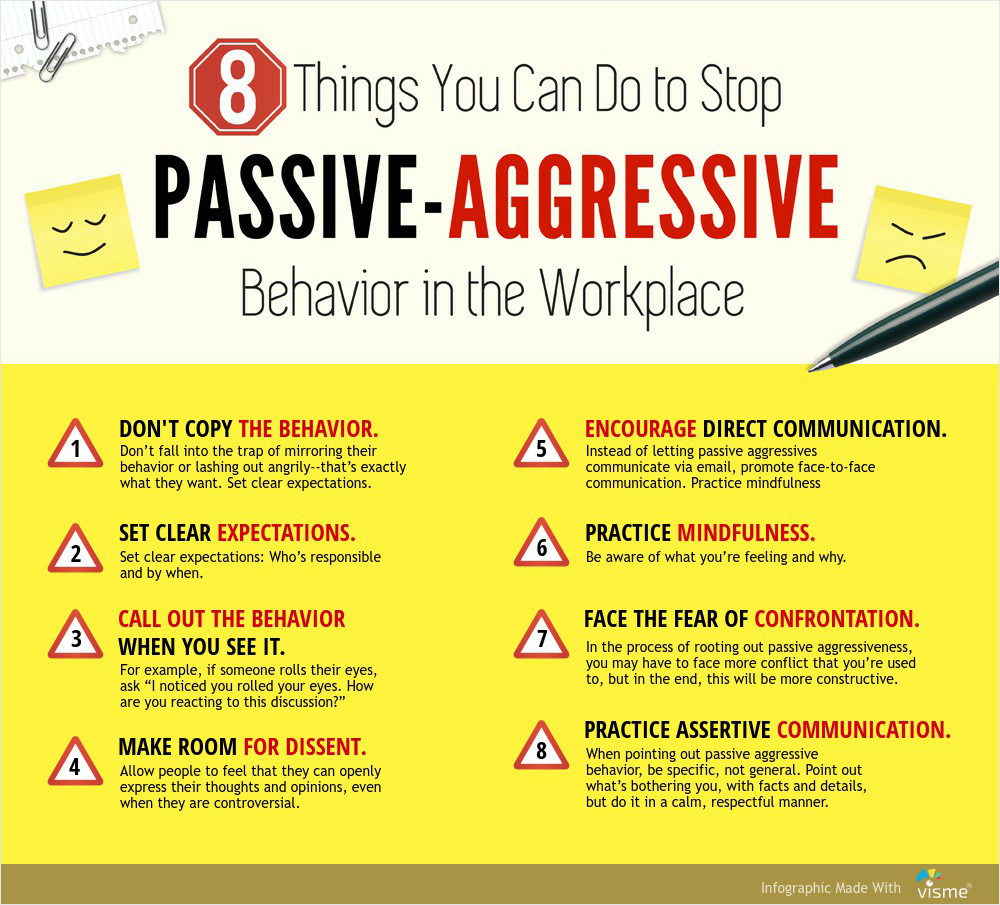What are the key points illustrated in this graphic about dealing with passive-aggressive behavior? The graphic outlines eight key strategies to address and mitigate passive-aggressive behavior in the workplace:

1. DON'T COPY THE BEHAVIOR: Avoid mirroring passive-aggressive behavior and instead set clear expectations.
2. SET CLEAR EXPECTATIONS: Clearly define responsibilities and deadlines.
3. CALL OUT THE BEHAVIOR WHEN YOU SEE IT: Address passive-aggressive actions directly.
4. MAKE ROOM FOR DISSENT: Encourage open expression of thoughts and opinions, even if they are controversial.
5. ENCOURAGE DIRECT COMMUNICATION: Promote face-to-face communication over indirect methods.
6. PRACTICE MINDFULNESS: Be aware of your feelings and reactions.
7. FACE THE FEAR OF CONFRONTATION: Be prepared to confront passive-aggressive behavior constructively.
8. PRACTICE ASSERTIVE COMMUNICATION: Address issues calmly, specifically, and respectfully.  How can "Practicing Mindfulness" make a difference in addressing passive-aggressive behavior? Practicing mindfulness can significantly help in addressing passive-aggressive behavior by promoting self-awareness and emotional regulation. When you are mindful, you are more attuned to your thoughts, feelings, and reactions, allowing you to recognize and understand any frustration or annoyance you may be experiencing. This awareness helps you stay calm and composed, enabling you to respond to passive-aggressive behavior in a thoughtful and controlled manner. Instead of reacting impulsively, mindfulness encourages a more constructive approach, helping to de-escalate situations and fostering a more positive and respectful communication style.  Imagine this infographic had a character illustrating each point. Describe what the characters might look like and their actions for two of the strategies. For Strategy 1, "DON'T COPY THE BEHAVIOR": The character could be depicted as a calm businessperson standing confidently with a friendly, open posture. They might be shown setting boundaries by holding a clear list of expectations and responsibilities. This character would have a composed expression, demonstrating their commitment to maintaining a positive and constructive demeanor.

For Strategy 4, "MAKE ROOM FOR DISSENT": This character could be shown in a group meeting setting, encouraging diverse opinions. They might be depicted with an open hand gesture, inviting colleagues to share their viewpoints, even if they are controversial. The character would have a welcoming and sincere expression, promoting an atmosphere of trust and open communication. 